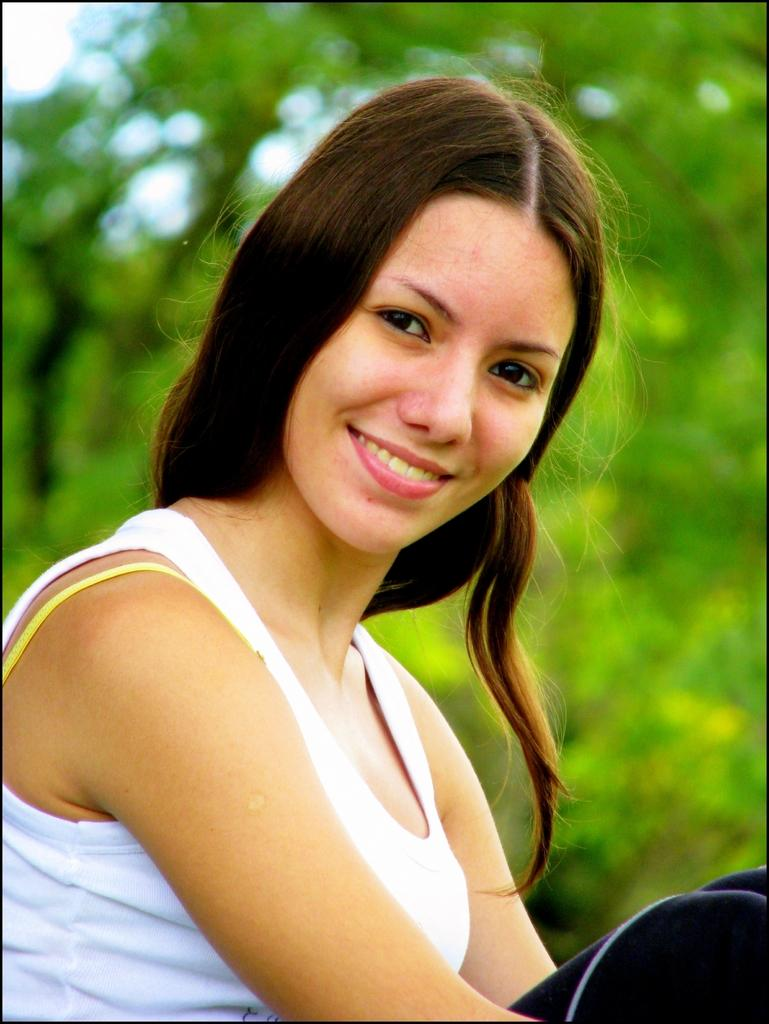Who is present in the image? There is a woman in the image. What is the woman's expression? The woman is smiling. What can be seen in the background of the image? There are trees in the background of the image. How would you describe the background's appearance? The background appears blurry. What type of toy can be seen in the woman's hand in the image? There is no toy present in the woman's hand or in the image. 